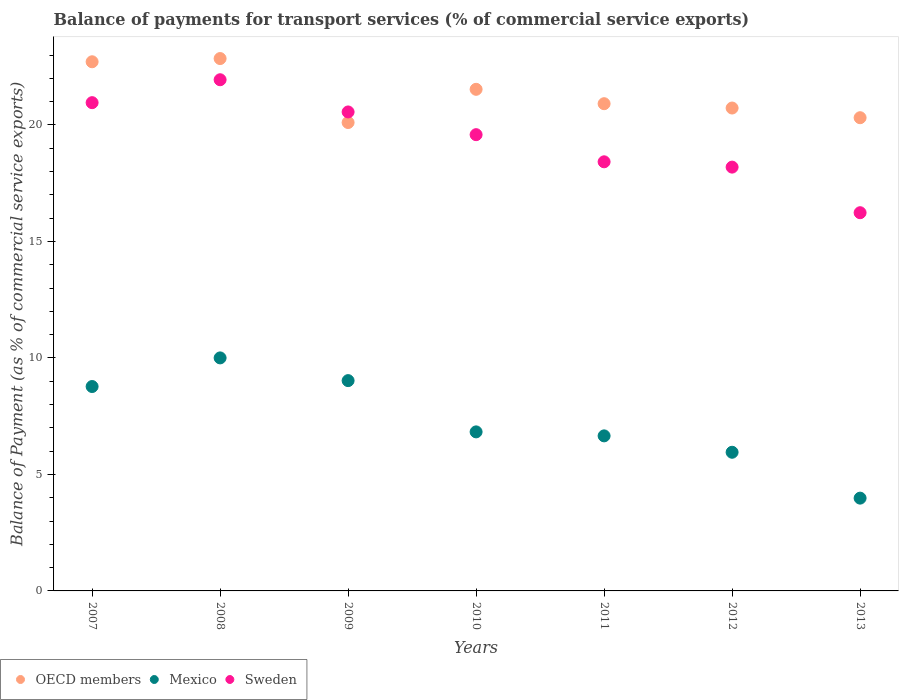What is the balance of payments for transport services in OECD members in 2012?
Give a very brief answer. 20.73. Across all years, what is the maximum balance of payments for transport services in OECD members?
Make the answer very short. 22.85. Across all years, what is the minimum balance of payments for transport services in Sweden?
Keep it short and to the point. 16.23. In which year was the balance of payments for transport services in OECD members maximum?
Offer a very short reply. 2008. What is the total balance of payments for transport services in OECD members in the graph?
Provide a succinct answer. 149.15. What is the difference between the balance of payments for transport services in OECD members in 2010 and that in 2013?
Your response must be concise. 1.22. What is the difference between the balance of payments for transport services in OECD members in 2011 and the balance of payments for transport services in Mexico in 2010?
Give a very brief answer. 14.09. What is the average balance of payments for transport services in Mexico per year?
Your answer should be very brief. 7.32. In the year 2009, what is the difference between the balance of payments for transport services in OECD members and balance of payments for transport services in Sweden?
Offer a terse response. -0.45. What is the ratio of the balance of payments for transport services in Mexico in 2007 to that in 2010?
Keep it short and to the point. 1.29. What is the difference between the highest and the second highest balance of payments for transport services in Mexico?
Provide a short and direct response. 0.98. What is the difference between the highest and the lowest balance of payments for transport services in Sweden?
Keep it short and to the point. 5.71. In how many years, is the balance of payments for transport services in Sweden greater than the average balance of payments for transport services in Sweden taken over all years?
Offer a very short reply. 4. Is the sum of the balance of payments for transport services in OECD members in 2007 and 2011 greater than the maximum balance of payments for transport services in Sweden across all years?
Give a very brief answer. Yes. Is it the case that in every year, the sum of the balance of payments for transport services in Sweden and balance of payments for transport services in Mexico  is greater than the balance of payments for transport services in OECD members?
Your response must be concise. No. Does the balance of payments for transport services in OECD members monotonically increase over the years?
Your answer should be very brief. No. Is the balance of payments for transport services in Sweden strictly greater than the balance of payments for transport services in OECD members over the years?
Your answer should be compact. No. What is the difference between two consecutive major ticks on the Y-axis?
Offer a very short reply. 5. How many legend labels are there?
Offer a terse response. 3. How are the legend labels stacked?
Give a very brief answer. Horizontal. What is the title of the graph?
Your response must be concise. Balance of payments for transport services (% of commercial service exports). Does "Ghana" appear as one of the legend labels in the graph?
Give a very brief answer. No. What is the label or title of the Y-axis?
Make the answer very short. Balance of Payment (as % of commercial service exports). What is the Balance of Payment (as % of commercial service exports) in OECD members in 2007?
Provide a short and direct response. 22.71. What is the Balance of Payment (as % of commercial service exports) of Mexico in 2007?
Keep it short and to the point. 8.77. What is the Balance of Payment (as % of commercial service exports) in Sweden in 2007?
Provide a short and direct response. 20.96. What is the Balance of Payment (as % of commercial service exports) in OECD members in 2008?
Your answer should be very brief. 22.85. What is the Balance of Payment (as % of commercial service exports) of Mexico in 2008?
Provide a short and direct response. 10. What is the Balance of Payment (as % of commercial service exports) of Sweden in 2008?
Keep it short and to the point. 21.94. What is the Balance of Payment (as % of commercial service exports) of OECD members in 2009?
Provide a short and direct response. 20.1. What is the Balance of Payment (as % of commercial service exports) of Mexico in 2009?
Ensure brevity in your answer.  9.03. What is the Balance of Payment (as % of commercial service exports) of Sweden in 2009?
Your response must be concise. 20.56. What is the Balance of Payment (as % of commercial service exports) in OECD members in 2010?
Your answer should be very brief. 21.53. What is the Balance of Payment (as % of commercial service exports) in Mexico in 2010?
Your answer should be compact. 6.83. What is the Balance of Payment (as % of commercial service exports) of Sweden in 2010?
Provide a short and direct response. 19.58. What is the Balance of Payment (as % of commercial service exports) in OECD members in 2011?
Provide a succinct answer. 20.91. What is the Balance of Payment (as % of commercial service exports) in Mexico in 2011?
Your answer should be compact. 6.65. What is the Balance of Payment (as % of commercial service exports) of Sweden in 2011?
Make the answer very short. 18.42. What is the Balance of Payment (as % of commercial service exports) of OECD members in 2012?
Give a very brief answer. 20.73. What is the Balance of Payment (as % of commercial service exports) in Mexico in 2012?
Provide a succinct answer. 5.95. What is the Balance of Payment (as % of commercial service exports) in Sweden in 2012?
Ensure brevity in your answer.  18.19. What is the Balance of Payment (as % of commercial service exports) in OECD members in 2013?
Provide a short and direct response. 20.31. What is the Balance of Payment (as % of commercial service exports) of Mexico in 2013?
Provide a short and direct response. 3.98. What is the Balance of Payment (as % of commercial service exports) of Sweden in 2013?
Keep it short and to the point. 16.23. Across all years, what is the maximum Balance of Payment (as % of commercial service exports) of OECD members?
Ensure brevity in your answer.  22.85. Across all years, what is the maximum Balance of Payment (as % of commercial service exports) in Mexico?
Your answer should be very brief. 10. Across all years, what is the maximum Balance of Payment (as % of commercial service exports) of Sweden?
Give a very brief answer. 21.94. Across all years, what is the minimum Balance of Payment (as % of commercial service exports) in OECD members?
Ensure brevity in your answer.  20.1. Across all years, what is the minimum Balance of Payment (as % of commercial service exports) in Mexico?
Ensure brevity in your answer.  3.98. Across all years, what is the minimum Balance of Payment (as % of commercial service exports) in Sweden?
Ensure brevity in your answer.  16.23. What is the total Balance of Payment (as % of commercial service exports) in OECD members in the graph?
Provide a short and direct response. 149.15. What is the total Balance of Payment (as % of commercial service exports) of Mexico in the graph?
Make the answer very short. 51.22. What is the total Balance of Payment (as % of commercial service exports) in Sweden in the graph?
Provide a short and direct response. 135.88. What is the difference between the Balance of Payment (as % of commercial service exports) of OECD members in 2007 and that in 2008?
Your answer should be compact. -0.14. What is the difference between the Balance of Payment (as % of commercial service exports) in Mexico in 2007 and that in 2008?
Keep it short and to the point. -1.23. What is the difference between the Balance of Payment (as % of commercial service exports) of Sweden in 2007 and that in 2008?
Your answer should be very brief. -0.98. What is the difference between the Balance of Payment (as % of commercial service exports) of OECD members in 2007 and that in 2009?
Offer a very short reply. 2.61. What is the difference between the Balance of Payment (as % of commercial service exports) of Mexico in 2007 and that in 2009?
Offer a terse response. -0.25. What is the difference between the Balance of Payment (as % of commercial service exports) in Sweden in 2007 and that in 2009?
Make the answer very short. 0.4. What is the difference between the Balance of Payment (as % of commercial service exports) in OECD members in 2007 and that in 2010?
Give a very brief answer. 1.18. What is the difference between the Balance of Payment (as % of commercial service exports) of Mexico in 2007 and that in 2010?
Ensure brevity in your answer.  1.95. What is the difference between the Balance of Payment (as % of commercial service exports) in Sweden in 2007 and that in 2010?
Ensure brevity in your answer.  1.37. What is the difference between the Balance of Payment (as % of commercial service exports) of OECD members in 2007 and that in 2011?
Your answer should be very brief. 1.8. What is the difference between the Balance of Payment (as % of commercial service exports) of Mexico in 2007 and that in 2011?
Your response must be concise. 2.12. What is the difference between the Balance of Payment (as % of commercial service exports) in Sweden in 2007 and that in 2011?
Ensure brevity in your answer.  2.54. What is the difference between the Balance of Payment (as % of commercial service exports) of OECD members in 2007 and that in 2012?
Your response must be concise. 1.99. What is the difference between the Balance of Payment (as % of commercial service exports) in Mexico in 2007 and that in 2012?
Offer a very short reply. 2.82. What is the difference between the Balance of Payment (as % of commercial service exports) of Sweden in 2007 and that in 2012?
Make the answer very short. 2.77. What is the difference between the Balance of Payment (as % of commercial service exports) in OECD members in 2007 and that in 2013?
Your response must be concise. 2.4. What is the difference between the Balance of Payment (as % of commercial service exports) of Mexico in 2007 and that in 2013?
Keep it short and to the point. 4.79. What is the difference between the Balance of Payment (as % of commercial service exports) in Sweden in 2007 and that in 2013?
Keep it short and to the point. 4.72. What is the difference between the Balance of Payment (as % of commercial service exports) of OECD members in 2008 and that in 2009?
Make the answer very short. 2.75. What is the difference between the Balance of Payment (as % of commercial service exports) in Mexico in 2008 and that in 2009?
Provide a short and direct response. 0.98. What is the difference between the Balance of Payment (as % of commercial service exports) of Sweden in 2008 and that in 2009?
Keep it short and to the point. 1.38. What is the difference between the Balance of Payment (as % of commercial service exports) in OECD members in 2008 and that in 2010?
Offer a very short reply. 1.32. What is the difference between the Balance of Payment (as % of commercial service exports) in Mexico in 2008 and that in 2010?
Keep it short and to the point. 3.18. What is the difference between the Balance of Payment (as % of commercial service exports) of Sweden in 2008 and that in 2010?
Provide a short and direct response. 2.36. What is the difference between the Balance of Payment (as % of commercial service exports) in OECD members in 2008 and that in 2011?
Ensure brevity in your answer.  1.94. What is the difference between the Balance of Payment (as % of commercial service exports) in Mexico in 2008 and that in 2011?
Give a very brief answer. 3.35. What is the difference between the Balance of Payment (as % of commercial service exports) of Sweden in 2008 and that in 2011?
Make the answer very short. 3.52. What is the difference between the Balance of Payment (as % of commercial service exports) of OECD members in 2008 and that in 2012?
Keep it short and to the point. 2.12. What is the difference between the Balance of Payment (as % of commercial service exports) in Mexico in 2008 and that in 2012?
Your response must be concise. 4.05. What is the difference between the Balance of Payment (as % of commercial service exports) in Sweden in 2008 and that in 2012?
Give a very brief answer. 3.75. What is the difference between the Balance of Payment (as % of commercial service exports) in OECD members in 2008 and that in 2013?
Your answer should be compact. 2.54. What is the difference between the Balance of Payment (as % of commercial service exports) of Mexico in 2008 and that in 2013?
Provide a short and direct response. 6.02. What is the difference between the Balance of Payment (as % of commercial service exports) in Sweden in 2008 and that in 2013?
Give a very brief answer. 5.71. What is the difference between the Balance of Payment (as % of commercial service exports) in OECD members in 2009 and that in 2010?
Make the answer very short. -1.43. What is the difference between the Balance of Payment (as % of commercial service exports) in Mexico in 2009 and that in 2010?
Your answer should be compact. 2.2. What is the difference between the Balance of Payment (as % of commercial service exports) of Sweden in 2009 and that in 2010?
Provide a succinct answer. 0.98. What is the difference between the Balance of Payment (as % of commercial service exports) of OECD members in 2009 and that in 2011?
Your response must be concise. -0.81. What is the difference between the Balance of Payment (as % of commercial service exports) in Mexico in 2009 and that in 2011?
Offer a very short reply. 2.37. What is the difference between the Balance of Payment (as % of commercial service exports) of Sweden in 2009 and that in 2011?
Offer a very short reply. 2.14. What is the difference between the Balance of Payment (as % of commercial service exports) in OECD members in 2009 and that in 2012?
Provide a succinct answer. -0.62. What is the difference between the Balance of Payment (as % of commercial service exports) in Mexico in 2009 and that in 2012?
Your response must be concise. 3.08. What is the difference between the Balance of Payment (as % of commercial service exports) of Sweden in 2009 and that in 2012?
Ensure brevity in your answer.  2.37. What is the difference between the Balance of Payment (as % of commercial service exports) in OECD members in 2009 and that in 2013?
Your response must be concise. -0.21. What is the difference between the Balance of Payment (as % of commercial service exports) of Mexico in 2009 and that in 2013?
Make the answer very short. 5.04. What is the difference between the Balance of Payment (as % of commercial service exports) in Sweden in 2009 and that in 2013?
Your response must be concise. 4.32. What is the difference between the Balance of Payment (as % of commercial service exports) in OECD members in 2010 and that in 2011?
Provide a succinct answer. 0.62. What is the difference between the Balance of Payment (as % of commercial service exports) in Mexico in 2010 and that in 2011?
Ensure brevity in your answer.  0.17. What is the difference between the Balance of Payment (as % of commercial service exports) in Sweden in 2010 and that in 2011?
Ensure brevity in your answer.  1.17. What is the difference between the Balance of Payment (as % of commercial service exports) of OECD members in 2010 and that in 2012?
Provide a short and direct response. 0.8. What is the difference between the Balance of Payment (as % of commercial service exports) of Mexico in 2010 and that in 2012?
Keep it short and to the point. 0.87. What is the difference between the Balance of Payment (as % of commercial service exports) of Sweden in 2010 and that in 2012?
Ensure brevity in your answer.  1.39. What is the difference between the Balance of Payment (as % of commercial service exports) in OECD members in 2010 and that in 2013?
Keep it short and to the point. 1.22. What is the difference between the Balance of Payment (as % of commercial service exports) in Mexico in 2010 and that in 2013?
Provide a short and direct response. 2.84. What is the difference between the Balance of Payment (as % of commercial service exports) of Sweden in 2010 and that in 2013?
Ensure brevity in your answer.  3.35. What is the difference between the Balance of Payment (as % of commercial service exports) in OECD members in 2011 and that in 2012?
Ensure brevity in your answer.  0.19. What is the difference between the Balance of Payment (as % of commercial service exports) in Mexico in 2011 and that in 2012?
Offer a terse response. 0.7. What is the difference between the Balance of Payment (as % of commercial service exports) in Sweden in 2011 and that in 2012?
Provide a short and direct response. 0.23. What is the difference between the Balance of Payment (as % of commercial service exports) in OECD members in 2011 and that in 2013?
Make the answer very short. 0.6. What is the difference between the Balance of Payment (as % of commercial service exports) of Mexico in 2011 and that in 2013?
Your answer should be compact. 2.67. What is the difference between the Balance of Payment (as % of commercial service exports) in Sweden in 2011 and that in 2013?
Offer a terse response. 2.18. What is the difference between the Balance of Payment (as % of commercial service exports) in OECD members in 2012 and that in 2013?
Make the answer very short. 0.42. What is the difference between the Balance of Payment (as % of commercial service exports) in Mexico in 2012 and that in 2013?
Your response must be concise. 1.97. What is the difference between the Balance of Payment (as % of commercial service exports) of Sweden in 2012 and that in 2013?
Offer a terse response. 1.96. What is the difference between the Balance of Payment (as % of commercial service exports) in OECD members in 2007 and the Balance of Payment (as % of commercial service exports) in Mexico in 2008?
Make the answer very short. 12.71. What is the difference between the Balance of Payment (as % of commercial service exports) of OECD members in 2007 and the Balance of Payment (as % of commercial service exports) of Sweden in 2008?
Your answer should be very brief. 0.77. What is the difference between the Balance of Payment (as % of commercial service exports) in Mexico in 2007 and the Balance of Payment (as % of commercial service exports) in Sweden in 2008?
Ensure brevity in your answer.  -13.17. What is the difference between the Balance of Payment (as % of commercial service exports) in OECD members in 2007 and the Balance of Payment (as % of commercial service exports) in Mexico in 2009?
Make the answer very short. 13.69. What is the difference between the Balance of Payment (as % of commercial service exports) of OECD members in 2007 and the Balance of Payment (as % of commercial service exports) of Sweden in 2009?
Give a very brief answer. 2.15. What is the difference between the Balance of Payment (as % of commercial service exports) in Mexico in 2007 and the Balance of Payment (as % of commercial service exports) in Sweden in 2009?
Provide a short and direct response. -11.79. What is the difference between the Balance of Payment (as % of commercial service exports) of OECD members in 2007 and the Balance of Payment (as % of commercial service exports) of Mexico in 2010?
Give a very brief answer. 15.89. What is the difference between the Balance of Payment (as % of commercial service exports) in OECD members in 2007 and the Balance of Payment (as % of commercial service exports) in Sweden in 2010?
Provide a succinct answer. 3.13. What is the difference between the Balance of Payment (as % of commercial service exports) of Mexico in 2007 and the Balance of Payment (as % of commercial service exports) of Sweden in 2010?
Make the answer very short. -10.81. What is the difference between the Balance of Payment (as % of commercial service exports) in OECD members in 2007 and the Balance of Payment (as % of commercial service exports) in Mexico in 2011?
Your answer should be compact. 16.06. What is the difference between the Balance of Payment (as % of commercial service exports) in OECD members in 2007 and the Balance of Payment (as % of commercial service exports) in Sweden in 2011?
Keep it short and to the point. 4.29. What is the difference between the Balance of Payment (as % of commercial service exports) of Mexico in 2007 and the Balance of Payment (as % of commercial service exports) of Sweden in 2011?
Make the answer very short. -9.65. What is the difference between the Balance of Payment (as % of commercial service exports) in OECD members in 2007 and the Balance of Payment (as % of commercial service exports) in Mexico in 2012?
Offer a very short reply. 16.76. What is the difference between the Balance of Payment (as % of commercial service exports) of OECD members in 2007 and the Balance of Payment (as % of commercial service exports) of Sweden in 2012?
Ensure brevity in your answer.  4.52. What is the difference between the Balance of Payment (as % of commercial service exports) in Mexico in 2007 and the Balance of Payment (as % of commercial service exports) in Sweden in 2012?
Your answer should be compact. -9.42. What is the difference between the Balance of Payment (as % of commercial service exports) in OECD members in 2007 and the Balance of Payment (as % of commercial service exports) in Mexico in 2013?
Your answer should be compact. 18.73. What is the difference between the Balance of Payment (as % of commercial service exports) in OECD members in 2007 and the Balance of Payment (as % of commercial service exports) in Sweden in 2013?
Your answer should be compact. 6.48. What is the difference between the Balance of Payment (as % of commercial service exports) in Mexico in 2007 and the Balance of Payment (as % of commercial service exports) in Sweden in 2013?
Offer a very short reply. -7.46. What is the difference between the Balance of Payment (as % of commercial service exports) of OECD members in 2008 and the Balance of Payment (as % of commercial service exports) of Mexico in 2009?
Keep it short and to the point. 13.82. What is the difference between the Balance of Payment (as % of commercial service exports) in OECD members in 2008 and the Balance of Payment (as % of commercial service exports) in Sweden in 2009?
Make the answer very short. 2.29. What is the difference between the Balance of Payment (as % of commercial service exports) of Mexico in 2008 and the Balance of Payment (as % of commercial service exports) of Sweden in 2009?
Your answer should be very brief. -10.56. What is the difference between the Balance of Payment (as % of commercial service exports) of OECD members in 2008 and the Balance of Payment (as % of commercial service exports) of Mexico in 2010?
Provide a short and direct response. 16.02. What is the difference between the Balance of Payment (as % of commercial service exports) of OECD members in 2008 and the Balance of Payment (as % of commercial service exports) of Sweden in 2010?
Provide a succinct answer. 3.27. What is the difference between the Balance of Payment (as % of commercial service exports) of Mexico in 2008 and the Balance of Payment (as % of commercial service exports) of Sweden in 2010?
Ensure brevity in your answer.  -9.58. What is the difference between the Balance of Payment (as % of commercial service exports) of OECD members in 2008 and the Balance of Payment (as % of commercial service exports) of Mexico in 2011?
Give a very brief answer. 16.2. What is the difference between the Balance of Payment (as % of commercial service exports) of OECD members in 2008 and the Balance of Payment (as % of commercial service exports) of Sweden in 2011?
Your answer should be very brief. 4.43. What is the difference between the Balance of Payment (as % of commercial service exports) of Mexico in 2008 and the Balance of Payment (as % of commercial service exports) of Sweden in 2011?
Provide a short and direct response. -8.42. What is the difference between the Balance of Payment (as % of commercial service exports) in OECD members in 2008 and the Balance of Payment (as % of commercial service exports) in Mexico in 2012?
Your response must be concise. 16.9. What is the difference between the Balance of Payment (as % of commercial service exports) in OECD members in 2008 and the Balance of Payment (as % of commercial service exports) in Sweden in 2012?
Your answer should be very brief. 4.66. What is the difference between the Balance of Payment (as % of commercial service exports) in Mexico in 2008 and the Balance of Payment (as % of commercial service exports) in Sweden in 2012?
Provide a succinct answer. -8.19. What is the difference between the Balance of Payment (as % of commercial service exports) in OECD members in 2008 and the Balance of Payment (as % of commercial service exports) in Mexico in 2013?
Provide a short and direct response. 18.87. What is the difference between the Balance of Payment (as % of commercial service exports) in OECD members in 2008 and the Balance of Payment (as % of commercial service exports) in Sweden in 2013?
Keep it short and to the point. 6.62. What is the difference between the Balance of Payment (as % of commercial service exports) of Mexico in 2008 and the Balance of Payment (as % of commercial service exports) of Sweden in 2013?
Your response must be concise. -6.23. What is the difference between the Balance of Payment (as % of commercial service exports) of OECD members in 2009 and the Balance of Payment (as % of commercial service exports) of Mexico in 2010?
Ensure brevity in your answer.  13.28. What is the difference between the Balance of Payment (as % of commercial service exports) in OECD members in 2009 and the Balance of Payment (as % of commercial service exports) in Sweden in 2010?
Your answer should be compact. 0.52. What is the difference between the Balance of Payment (as % of commercial service exports) in Mexico in 2009 and the Balance of Payment (as % of commercial service exports) in Sweden in 2010?
Offer a very short reply. -10.56. What is the difference between the Balance of Payment (as % of commercial service exports) in OECD members in 2009 and the Balance of Payment (as % of commercial service exports) in Mexico in 2011?
Your response must be concise. 13.45. What is the difference between the Balance of Payment (as % of commercial service exports) in OECD members in 2009 and the Balance of Payment (as % of commercial service exports) in Sweden in 2011?
Offer a terse response. 1.69. What is the difference between the Balance of Payment (as % of commercial service exports) in Mexico in 2009 and the Balance of Payment (as % of commercial service exports) in Sweden in 2011?
Keep it short and to the point. -9.39. What is the difference between the Balance of Payment (as % of commercial service exports) in OECD members in 2009 and the Balance of Payment (as % of commercial service exports) in Mexico in 2012?
Provide a succinct answer. 14.15. What is the difference between the Balance of Payment (as % of commercial service exports) in OECD members in 2009 and the Balance of Payment (as % of commercial service exports) in Sweden in 2012?
Ensure brevity in your answer.  1.91. What is the difference between the Balance of Payment (as % of commercial service exports) in Mexico in 2009 and the Balance of Payment (as % of commercial service exports) in Sweden in 2012?
Provide a succinct answer. -9.16. What is the difference between the Balance of Payment (as % of commercial service exports) in OECD members in 2009 and the Balance of Payment (as % of commercial service exports) in Mexico in 2013?
Keep it short and to the point. 16.12. What is the difference between the Balance of Payment (as % of commercial service exports) of OECD members in 2009 and the Balance of Payment (as % of commercial service exports) of Sweden in 2013?
Provide a short and direct response. 3.87. What is the difference between the Balance of Payment (as % of commercial service exports) in Mexico in 2009 and the Balance of Payment (as % of commercial service exports) in Sweden in 2013?
Keep it short and to the point. -7.21. What is the difference between the Balance of Payment (as % of commercial service exports) in OECD members in 2010 and the Balance of Payment (as % of commercial service exports) in Mexico in 2011?
Offer a terse response. 14.87. What is the difference between the Balance of Payment (as % of commercial service exports) of OECD members in 2010 and the Balance of Payment (as % of commercial service exports) of Sweden in 2011?
Ensure brevity in your answer.  3.11. What is the difference between the Balance of Payment (as % of commercial service exports) of Mexico in 2010 and the Balance of Payment (as % of commercial service exports) of Sweden in 2011?
Your response must be concise. -11.59. What is the difference between the Balance of Payment (as % of commercial service exports) in OECD members in 2010 and the Balance of Payment (as % of commercial service exports) in Mexico in 2012?
Give a very brief answer. 15.58. What is the difference between the Balance of Payment (as % of commercial service exports) in OECD members in 2010 and the Balance of Payment (as % of commercial service exports) in Sweden in 2012?
Ensure brevity in your answer.  3.34. What is the difference between the Balance of Payment (as % of commercial service exports) of Mexico in 2010 and the Balance of Payment (as % of commercial service exports) of Sweden in 2012?
Offer a terse response. -11.36. What is the difference between the Balance of Payment (as % of commercial service exports) of OECD members in 2010 and the Balance of Payment (as % of commercial service exports) of Mexico in 2013?
Give a very brief answer. 17.55. What is the difference between the Balance of Payment (as % of commercial service exports) in OECD members in 2010 and the Balance of Payment (as % of commercial service exports) in Sweden in 2013?
Ensure brevity in your answer.  5.3. What is the difference between the Balance of Payment (as % of commercial service exports) of Mexico in 2010 and the Balance of Payment (as % of commercial service exports) of Sweden in 2013?
Ensure brevity in your answer.  -9.41. What is the difference between the Balance of Payment (as % of commercial service exports) of OECD members in 2011 and the Balance of Payment (as % of commercial service exports) of Mexico in 2012?
Give a very brief answer. 14.96. What is the difference between the Balance of Payment (as % of commercial service exports) of OECD members in 2011 and the Balance of Payment (as % of commercial service exports) of Sweden in 2012?
Keep it short and to the point. 2.72. What is the difference between the Balance of Payment (as % of commercial service exports) in Mexico in 2011 and the Balance of Payment (as % of commercial service exports) in Sweden in 2012?
Offer a terse response. -11.54. What is the difference between the Balance of Payment (as % of commercial service exports) of OECD members in 2011 and the Balance of Payment (as % of commercial service exports) of Mexico in 2013?
Make the answer very short. 16.93. What is the difference between the Balance of Payment (as % of commercial service exports) in OECD members in 2011 and the Balance of Payment (as % of commercial service exports) in Sweden in 2013?
Your answer should be very brief. 4.68. What is the difference between the Balance of Payment (as % of commercial service exports) in Mexico in 2011 and the Balance of Payment (as % of commercial service exports) in Sweden in 2013?
Your answer should be compact. -9.58. What is the difference between the Balance of Payment (as % of commercial service exports) of OECD members in 2012 and the Balance of Payment (as % of commercial service exports) of Mexico in 2013?
Ensure brevity in your answer.  16.74. What is the difference between the Balance of Payment (as % of commercial service exports) in OECD members in 2012 and the Balance of Payment (as % of commercial service exports) in Sweden in 2013?
Your response must be concise. 4.49. What is the difference between the Balance of Payment (as % of commercial service exports) in Mexico in 2012 and the Balance of Payment (as % of commercial service exports) in Sweden in 2013?
Keep it short and to the point. -10.28. What is the average Balance of Payment (as % of commercial service exports) in OECD members per year?
Provide a succinct answer. 21.31. What is the average Balance of Payment (as % of commercial service exports) in Mexico per year?
Your answer should be very brief. 7.32. What is the average Balance of Payment (as % of commercial service exports) in Sweden per year?
Your answer should be compact. 19.41. In the year 2007, what is the difference between the Balance of Payment (as % of commercial service exports) in OECD members and Balance of Payment (as % of commercial service exports) in Mexico?
Provide a succinct answer. 13.94. In the year 2007, what is the difference between the Balance of Payment (as % of commercial service exports) of OECD members and Balance of Payment (as % of commercial service exports) of Sweden?
Your answer should be very brief. 1.75. In the year 2007, what is the difference between the Balance of Payment (as % of commercial service exports) in Mexico and Balance of Payment (as % of commercial service exports) in Sweden?
Provide a short and direct response. -12.18. In the year 2008, what is the difference between the Balance of Payment (as % of commercial service exports) in OECD members and Balance of Payment (as % of commercial service exports) in Mexico?
Provide a succinct answer. 12.85. In the year 2008, what is the difference between the Balance of Payment (as % of commercial service exports) of OECD members and Balance of Payment (as % of commercial service exports) of Sweden?
Ensure brevity in your answer.  0.91. In the year 2008, what is the difference between the Balance of Payment (as % of commercial service exports) in Mexico and Balance of Payment (as % of commercial service exports) in Sweden?
Give a very brief answer. -11.94. In the year 2009, what is the difference between the Balance of Payment (as % of commercial service exports) of OECD members and Balance of Payment (as % of commercial service exports) of Mexico?
Keep it short and to the point. 11.08. In the year 2009, what is the difference between the Balance of Payment (as % of commercial service exports) of OECD members and Balance of Payment (as % of commercial service exports) of Sweden?
Your answer should be very brief. -0.45. In the year 2009, what is the difference between the Balance of Payment (as % of commercial service exports) in Mexico and Balance of Payment (as % of commercial service exports) in Sweden?
Provide a short and direct response. -11.53. In the year 2010, what is the difference between the Balance of Payment (as % of commercial service exports) in OECD members and Balance of Payment (as % of commercial service exports) in Mexico?
Your answer should be compact. 14.7. In the year 2010, what is the difference between the Balance of Payment (as % of commercial service exports) in OECD members and Balance of Payment (as % of commercial service exports) in Sweden?
Your response must be concise. 1.95. In the year 2010, what is the difference between the Balance of Payment (as % of commercial service exports) of Mexico and Balance of Payment (as % of commercial service exports) of Sweden?
Provide a short and direct response. -12.76. In the year 2011, what is the difference between the Balance of Payment (as % of commercial service exports) in OECD members and Balance of Payment (as % of commercial service exports) in Mexico?
Offer a very short reply. 14.26. In the year 2011, what is the difference between the Balance of Payment (as % of commercial service exports) in OECD members and Balance of Payment (as % of commercial service exports) in Sweden?
Your answer should be compact. 2.49. In the year 2011, what is the difference between the Balance of Payment (as % of commercial service exports) in Mexico and Balance of Payment (as % of commercial service exports) in Sweden?
Make the answer very short. -11.76. In the year 2012, what is the difference between the Balance of Payment (as % of commercial service exports) of OECD members and Balance of Payment (as % of commercial service exports) of Mexico?
Provide a short and direct response. 14.78. In the year 2012, what is the difference between the Balance of Payment (as % of commercial service exports) of OECD members and Balance of Payment (as % of commercial service exports) of Sweden?
Give a very brief answer. 2.54. In the year 2012, what is the difference between the Balance of Payment (as % of commercial service exports) of Mexico and Balance of Payment (as % of commercial service exports) of Sweden?
Provide a short and direct response. -12.24. In the year 2013, what is the difference between the Balance of Payment (as % of commercial service exports) in OECD members and Balance of Payment (as % of commercial service exports) in Mexico?
Your answer should be compact. 16.33. In the year 2013, what is the difference between the Balance of Payment (as % of commercial service exports) in OECD members and Balance of Payment (as % of commercial service exports) in Sweden?
Give a very brief answer. 4.08. In the year 2013, what is the difference between the Balance of Payment (as % of commercial service exports) of Mexico and Balance of Payment (as % of commercial service exports) of Sweden?
Offer a very short reply. -12.25. What is the ratio of the Balance of Payment (as % of commercial service exports) of Mexico in 2007 to that in 2008?
Provide a short and direct response. 0.88. What is the ratio of the Balance of Payment (as % of commercial service exports) of Sweden in 2007 to that in 2008?
Keep it short and to the point. 0.96. What is the ratio of the Balance of Payment (as % of commercial service exports) in OECD members in 2007 to that in 2009?
Your response must be concise. 1.13. What is the ratio of the Balance of Payment (as % of commercial service exports) of Mexico in 2007 to that in 2009?
Ensure brevity in your answer.  0.97. What is the ratio of the Balance of Payment (as % of commercial service exports) of Sweden in 2007 to that in 2009?
Make the answer very short. 1.02. What is the ratio of the Balance of Payment (as % of commercial service exports) of OECD members in 2007 to that in 2010?
Your response must be concise. 1.05. What is the ratio of the Balance of Payment (as % of commercial service exports) of Mexico in 2007 to that in 2010?
Provide a succinct answer. 1.29. What is the ratio of the Balance of Payment (as % of commercial service exports) of Sweden in 2007 to that in 2010?
Give a very brief answer. 1.07. What is the ratio of the Balance of Payment (as % of commercial service exports) of OECD members in 2007 to that in 2011?
Give a very brief answer. 1.09. What is the ratio of the Balance of Payment (as % of commercial service exports) in Mexico in 2007 to that in 2011?
Make the answer very short. 1.32. What is the ratio of the Balance of Payment (as % of commercial service exports) in Sweden in 2007 to that in 2011?
Offer a terse response. 1.14. What is the ratio of the Balance of Payment (as % of commercial service exports) of OECD members in 2007 to that in 2012?
Ensure brevity in your answer.  1.1. What is the ratio of the Balance of Payment (as % of commercial service exports) in Mexico in 2007 to that in 2012?
Offer a terse response. 1.47. What is the ratio of the Balance of Payment (as % of commercial service exports) in Sweden in 2007 to that in 2012?
Give a very brief answer. 1.15. What is the ratio of the Balance of Payment (as % of commercial service exports) in OECD members in 2007 to that in 2013?
Your answer should be compact. 1.12. What is the ratio of the Balance of Payment (as % of commercial service exports) of Mexico in 2007 to that in 2013?
Provide a short and direct response. 2.2. What is the ratio of the Balance of Payment (as % of commercial service exports) in Sweden in 2007 to that in 2013?
Your answer should be very brief. 1.29. What is the ratio of the Balance of Payment (as % of commercial service exports) in OECD members in 2008 to that in 2009?
Your answer should be compact. 1.14. What is the ratio of the Balance of Payment (as % of commercial service exports) of Mexico in 2008 to that in 2009?
Offer a very short reply. 1.11. What is the ratio of the Balance of Payment (as % of commercial service exports) in Sweden in 2008 to that in 2009?
Ensure brevity in your answer.  1.07. What is the ratio of the Balance of Payment (as % of commercial service exports) in OECD members in 2008 to that in 2010?
Provide a succinct answer. 1.06. What is the ratio of the Balance of Payment (as % of commercial service exports) of Mexico in 2008 to that in 2010?
Keep it short and to the point. 1.47. What is the ratio of the Balance of Payment (as % of commercial service exports) in Sweden in 2008 to that in 2010?
Provide a succinct answer. 1.12. What is the ratio of the Balance of Payment (as % of commercial service exports) of OECD members in 2008 to that in 2011?
Offer a terse response. 1.09. What is the ratio of the Balance of Payment (as % of commercial service exports) of Mexico in 2008 to that in 2011?
Ensure brevity in your answer.  1.5. What is the ratio of the Balance of Payment (as % of commercial service exports) in Sweden in 2008 to that in 2011?
Your answer should be very brief. 1.19. What is the ratio of the Balance of Payment (as % of commercial service exports) of OECD members in 2008 to that in 2012?
Your response must be concise. 1.1. What is the ratio of the Balance of Payment (as % of commercial service exports) of Mexico in 2008 to that in 2012?
Keep it short and to the point. 1.68. What is the ratio of the Balance of Payment (as % of commercial service exports) in Sweden in 2008 to that in 2012?
Keep it short and to the point. 1.21. What is the ratio of the Balance of Payment (as % of commercial service exports) in OECD members in 2008 to that in 2013?
Your answer should be compact. 1.12. What is the ratio of the Balance of Payment (as % of commercial service exports) in Mexico in 2008 to that in 2013?
Make the answer very short. 2.51. What is the ratio of the Balance of Payment (as % of commercial service exports) of Sweden in 2008 to that in 2013?
Provide a succinct answer. 1.35. What is the ratio of the Balance of Payment (as % of commercial service exports) in OECD members in 2009 to that in 2010?
Make the answer very short. 0.93. What is the ratio of the Balance of Payment (as % of commercial service exports) in Mexico in 2009 to that in 2010?
Your answer should be very brief. 1.32. What is the ratio of the Balance of Payment (as % of commercial service exports) in Sweden in 2009 to that in 2010?
Your answer should be very brief. 1.05. What is the ratio of the Balance of Payment (as % of commercial service exports) in OECD members in 2009 to that in 2011?
Ensure brevity in your answer.  0.96. What is the ratio of the Balance of Payment (as % of commercial service exports) in Mexico in 2009 to that in 2011?
Ensure brevity in your answer.  1.36. What is the ratio of the Balance of Payment (as % of commercial service exports) in Sweden in 2009 to that in 2011?
Provide a short and direct response. 1.12. What is the ratio of the Balance of Payment (as % of commercial service exports) of Mexico in 2009 to that in 2012?
Your response must be concise. 1.52. What is the ratio of the Balance of Payment (as % of commercial service exports) of Sweden in 2009 to that in 2012?
Provide a short and direct response. 1.13. What is the ratio of the Balance of Payment (as % of commercial service exports) of OECD members in 2009 to that in 2013?
Your answer should be very brief. 0.99. What is the ratio of the Balance of Payment (as % of commercial service exports) of Mexico in 2009 to that in 2013?
Provide a short and direct response. 2.27. What is the ratio of the Balance of Payment (as % of commercial service exports) of Sweden in 2009 to that in 2013?
Your answer should be compact. 1.27. What is the ratio of the Balance of Payment (as % of commercial service exports) of OECD members in 2010 to that in 2011?
Your response must be concise. 1.03. What is the ratio of the Balance of Payment (as % of commercial service exports) in Mexico in 2010 to that in 2011?
Your answer should be compact. 1.03. What is the ratio of the Balance of Payment (as % of commercial service exports) of Sweden in 2010 to that in 2011?
Your response must be concise. 1.06. What is the ratio of the Balance of Payment (as % of commercial service exports) of OECD members in 2010 to that in 2012?
Your answer should be compact. 1.04. What is the ratio of the Balance of Payment (as % of commercial service exports) in Mexico in 2010 to that in 2012?
Offer a terse response. 1.15. What is the ratio of the Balance of Payment (as % of commercial service exports) of Sweden in 2010 to that in 2012?
Your response must be concise. 1.08. What is the ratio of the Balance of Payment (as % of commercial service exports) of OECD members in 2010 to that in 2013?
Offer a terse response. 1.06. What is the ratio of the Balance of Payment (as % of commercial service exports) of Mexico in 2010 to that in 2013?
Your answer should be compact. 1.71. What is the ratio of the Balance of Payment (as % of commercial service exports) of Sweden in 2010 to that in 2013?
Your answer should be compact. 1.21. What is the ratio of the Balance of Payment (as % of commercial service exports) in OECD members in 2011 to that in 2012?
Offer a very short reply. 1.01. What is the ratio of the Balance of Payment (as % of commercial service exports) in Mexico in 2011 to that in 2012?
Your answer should be very brief. 1.12. What is the ratio of the Balance of Payment (as % of commercial service exports) of Sweden in 2011 to that in 2012?
Your answer should be compact. 1.01. What is the ratio of the Balance of Payment (as % of commercial service exports) of OECD members in 2011 to that in 2013?
Make the answer very short. 1.03. What is the ratio of the Balance of Payment (as % of commercial service exports) of Mexico in 2011 to that in 2013?
Ensure brevity in your answer.  1.67. What is the ratio of the Balance of Payment (as % of commercial service exports) of Sweden in 2011 to that in 2013?
Provide a short and direct response. 1.13. What is the ratio of the Balance of Payment (as % of commercial service exports) in OECD members in 2012 to that in 2013?
Keep it short and to the point. 1.02. What is the ratio of the Balance of Payment (as % of commercial service exports) of Mexico in 2012 to that in 2013?
Provide a short and direct response. 1.49. What is the ratio of the Balance of Payment (as % of commercial service exports) in Sweden in 2012 to that in 2013?
Your response must be concise. 1.12. What is the difference between the highest and the second highest Balance of Payment (as % of commercial service exports) in OECD members?
Your answer should be compact. 0.14. What is the difference between the highest and the second highest Balance of Payment (as % of commercial service exports) in Mexico?
Your response must be concise. 0.98. What is the difference between the highest and the second highest Balance of Payment (as % of commercial service exports) in Sweden?
Your answer should be very brief. 0.98. What is the difference between the highest and the lowest Balance of Payment (as % of commercial service exports) in OECD members?
Keep it short and to the point. 2.75. What is the difference between the highest and the lowest Balance of Payment (as % of commercial service exports) of Mexico?
Your answer should be very brief. 6.02. What is the difference between the highest and the lowest Balance of Payment (as % of commercial service exports) of Sweden?
Your response must be concise. 5.71. 